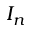Convert formula to latex. <formula><loc_0><loc_0><loc_500><loc_500>I _ { n }</formula> 